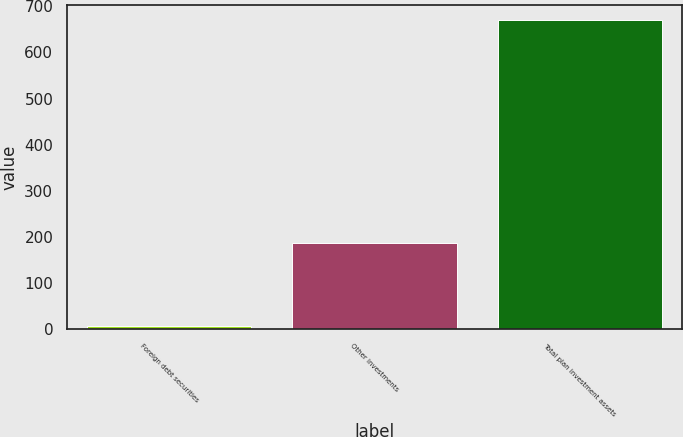Convert chart. <chart><loc_0><loc_0><loc_500><loc_500><bar_chart><fcel>Foreign debt securities<fcel>Other investments<fcel>Total plan investment assets<nl><fcel>6<fcel>187<fcel>670<nl></chart> 